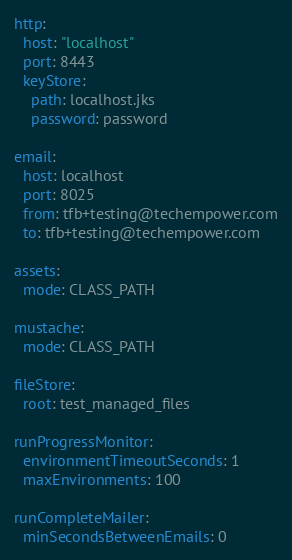<code> <loc_0><loc_0><loc_500><loc_500><_YAML_>http:
  host: "localhost"
  port: 8443
  keyStore:
    path: localhost.jks
    password: password

email:
  host: localhost
  port: 8025
  from: tfb+testing@techempower.com
  to: tfb+testing@techempower.com

assets:
  mode: CLASS_PATH

mustache:
  mode: CLASS_PATH

fileStore:
  root: test_managed_files

runProgressMonitor:
  environmentTimeoutSeconds: 1
  maxEnvironments: 100

runCompleteMailer:
  minSecondsBetweenEmails: 0
</code> 